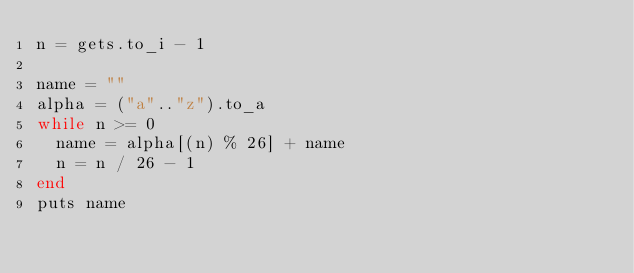<code> <loc_0><loc_0><loc_500><loc_500><_Ruby_>n = gets.to_i - 1

name = ""
alpha = ("a".."z").to_a
while n >= 0
  name = alpha[(n) % 26] + name
  n = n / 26 - 1
end
puts name
</code> 